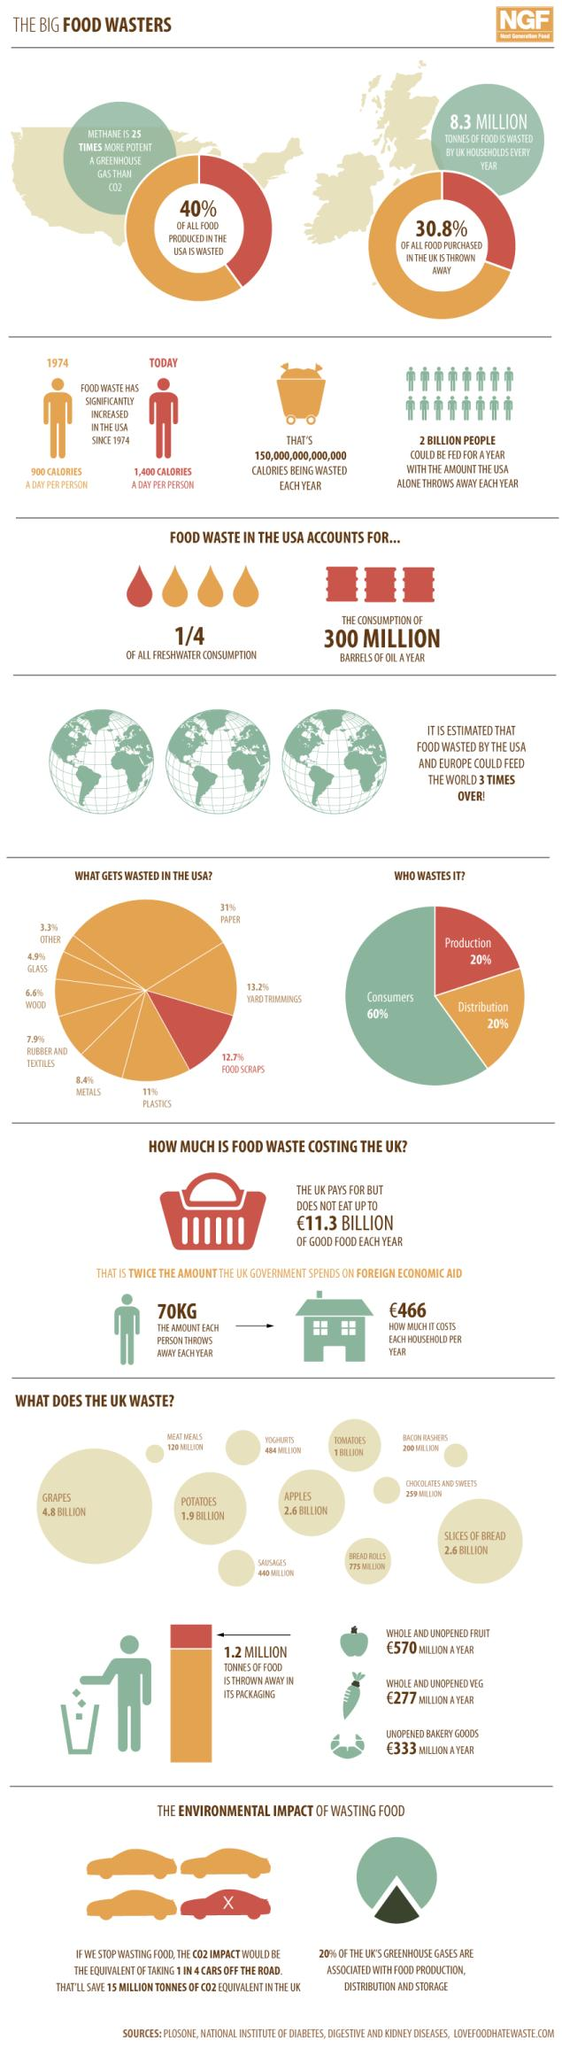Outline some significant characteristics in this image. The production industry generates approximately 20% of the waste in the United States. The amount of food waste produced per person in the U.S. in 1974 was approximately 900 calories per day. In the UK, approximately 775 million bread rolls are wasted each year. The amount of food waste generated by an individual person per year in the UK is approximately 70 kilograms. The UK generates 80% of its greenhouse gases that are not related to food production, distribution, and storage. 